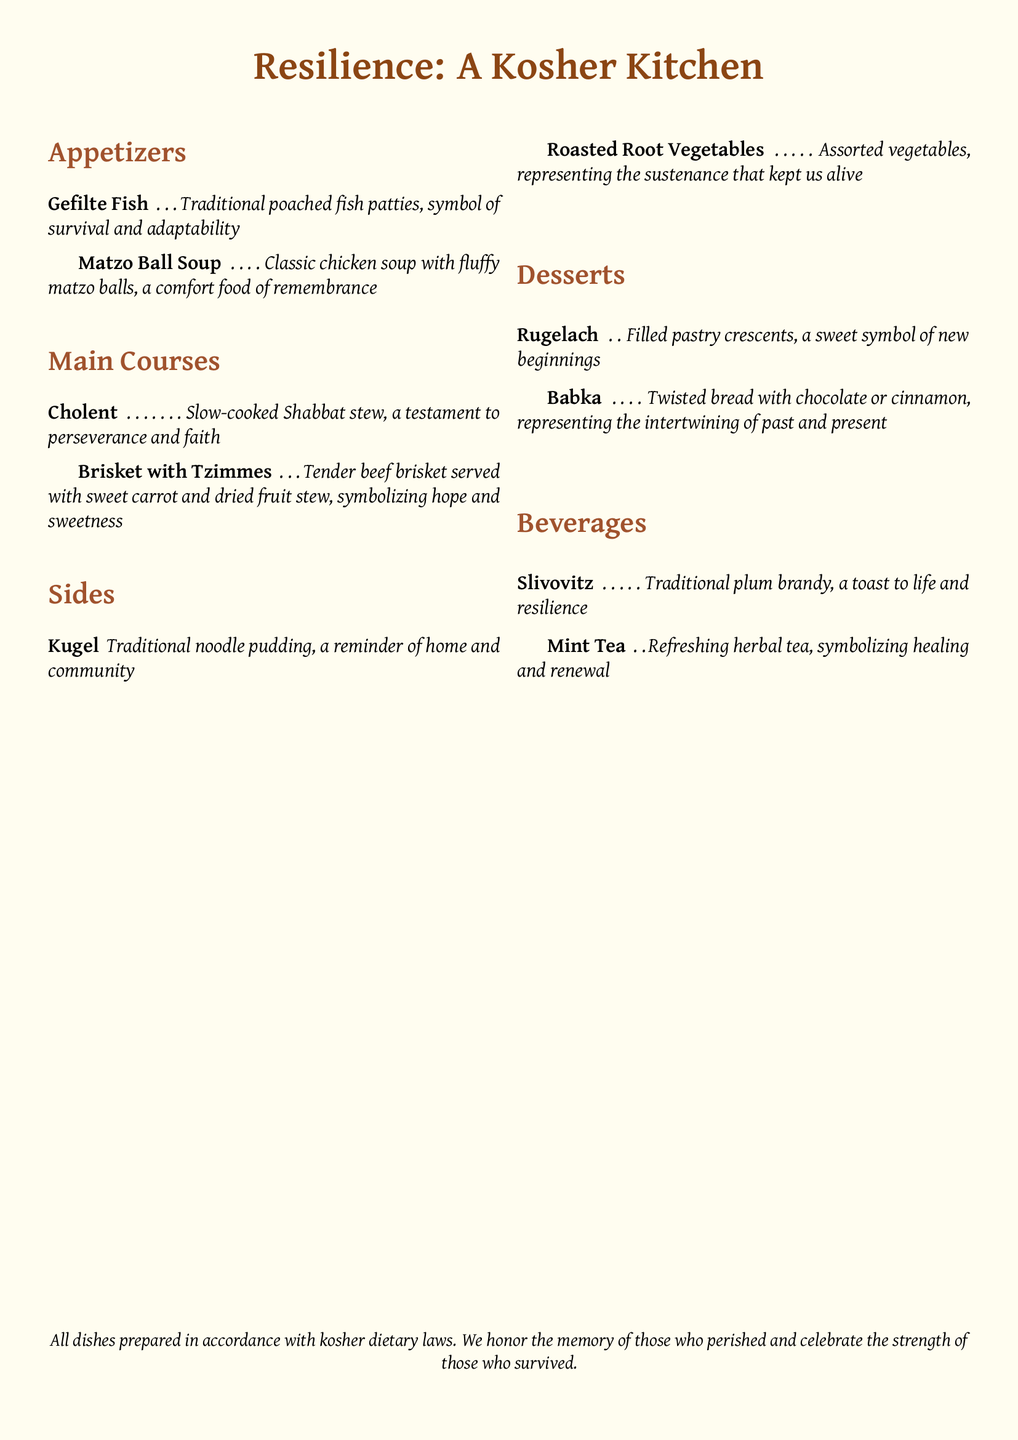What is the name of the first appetizer? The first appetizer listed in the menu is "Gefilte Fish."
Answer: Gefilte Fish What does "Babka" represent? The menu states that "Babka" represents the intertwining of past and present.
Answer: Intertwining of past and present What type of soup is served as an appetizer? The menu includes "Matzo Ball Soup" as the type of soup served.
Answer: Matzo Ball Soup How many main courses are listed? The document lists two main courses: "Cholent" and "Brisket with Tzimmes," totaling two.
Answer: 2 What is the significance of "Cholent"? "Cholent" is described as a testament to perseverance and faith.
Answer: Testament to perseverance and faith What dessert is associated with new beginnings? The dessert "Rugelach" is identified as a sweet symbol of new beginnings.
Answer: Rugelach Which beverage symbolizes healing and renewal? The document states that "Mint Tea" symbolizes healing and renewal.
Answer: Mint Tea What type of dietary laws are followed in the menu? The menu prepares all dishes in accordance with "kosher dietary laws."
Answer: Kosher dietary laws What is the last beverage listed? The last beverage listed is "Mint Tea."
Answer: Mint Tea 